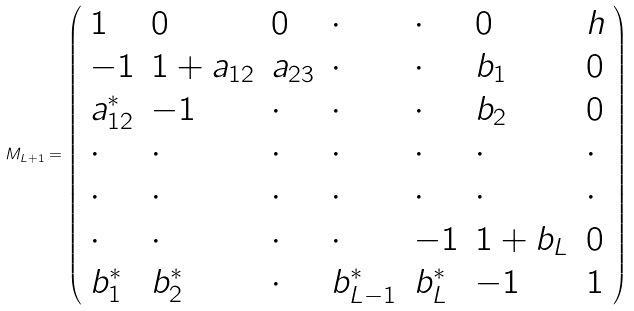Convert formula to latex. <formula><loc_0><loc_0><loc_500><loc_500>M _ { L + 1 } = \left ( \begin{array} { l l l l l l l } 1 & 0 & 0 & \cdot & \cdot & 0 & h \\ - 1 & 1 + a _ { 1 2 } & a _ { 2 3 } & \cdot & \cdot & b _ { 1 } & 0 \\ a _ { 1 2 } ^ { \ast } & - 1 & \cdot & \cdot & \cdot & b _ { 2 } & 0 \\ \cdot & \cdot & \cdot & \cdot & \cdot & \cdot & \cdot \\ \cdot & \cdot & \cdot & \cdot & \cdot & \cdot & \cdot \\ \cdot & \cdot & \cdot & \cdot & - 1 & 1 + b _ { L } & 0 \\ b _ { 1 } ^ { \ast } & b _ { 2 } ^ { \ast } & \cdot & b _ { L - 1 } ^ { \ast } & b _ { L } ^ { \ast } & - 1 & 1 \end{array} \right )</formula> 